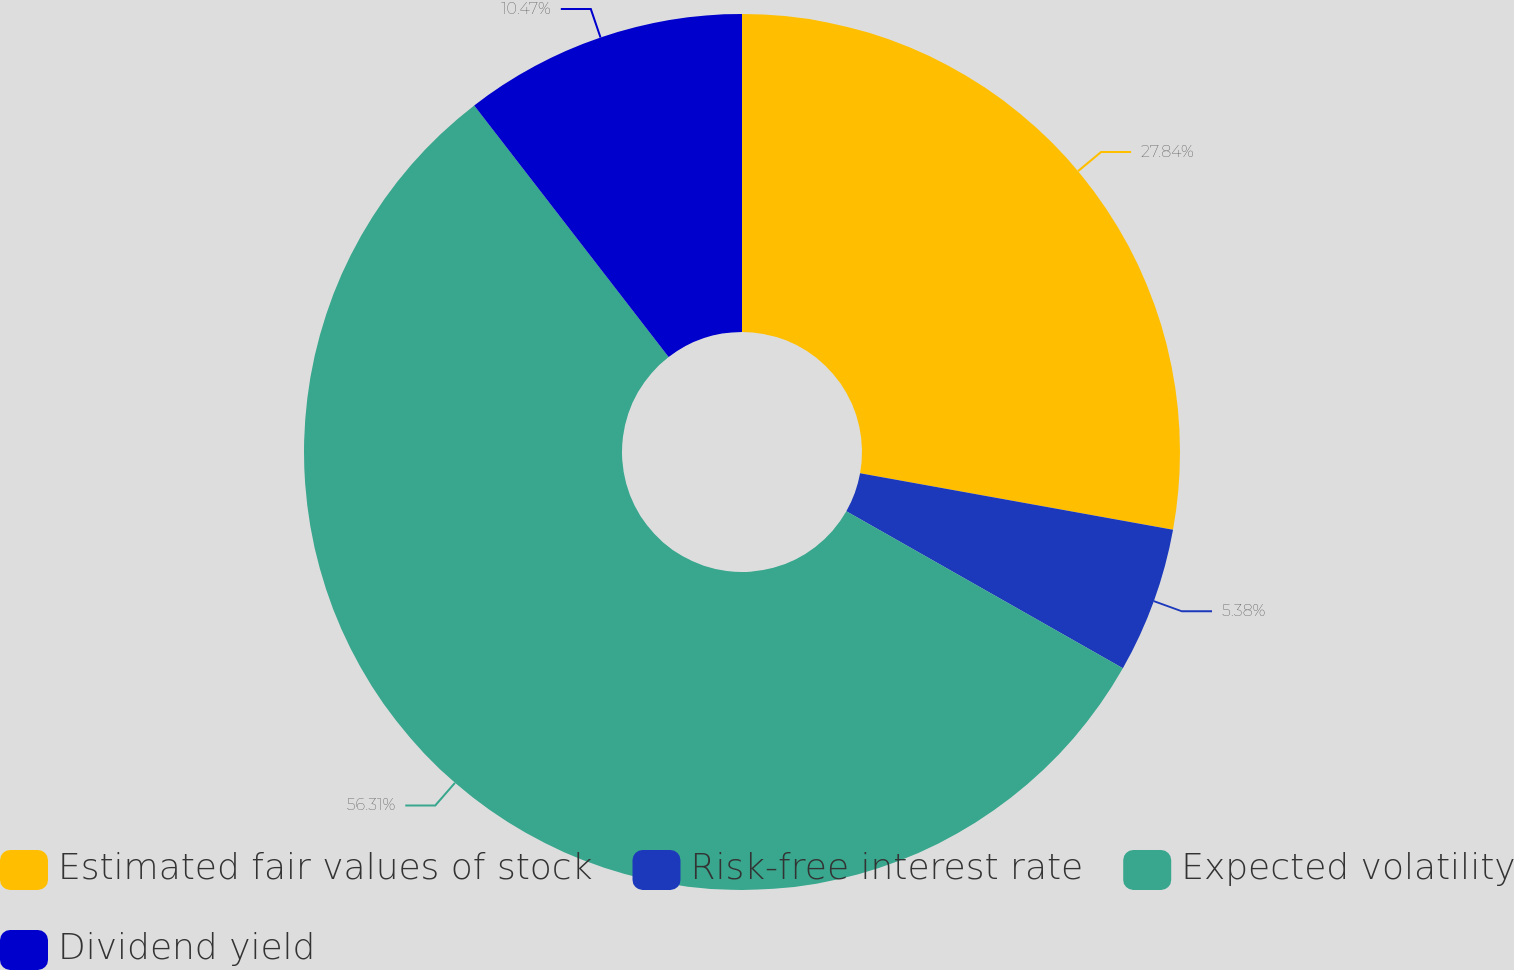Convert chart. <chart><loc_0><loc_0><loc_500><loc_500><pie_chart><fcel>Estimated fair values of stock<fcel>Risk-free interest rate<fcel>Expected volatility<fcel>Dividend yield<nl><fcel>27.84%<fcel>5.38%<fcel>56.31%<fcel>10.47%<nl></chart> 